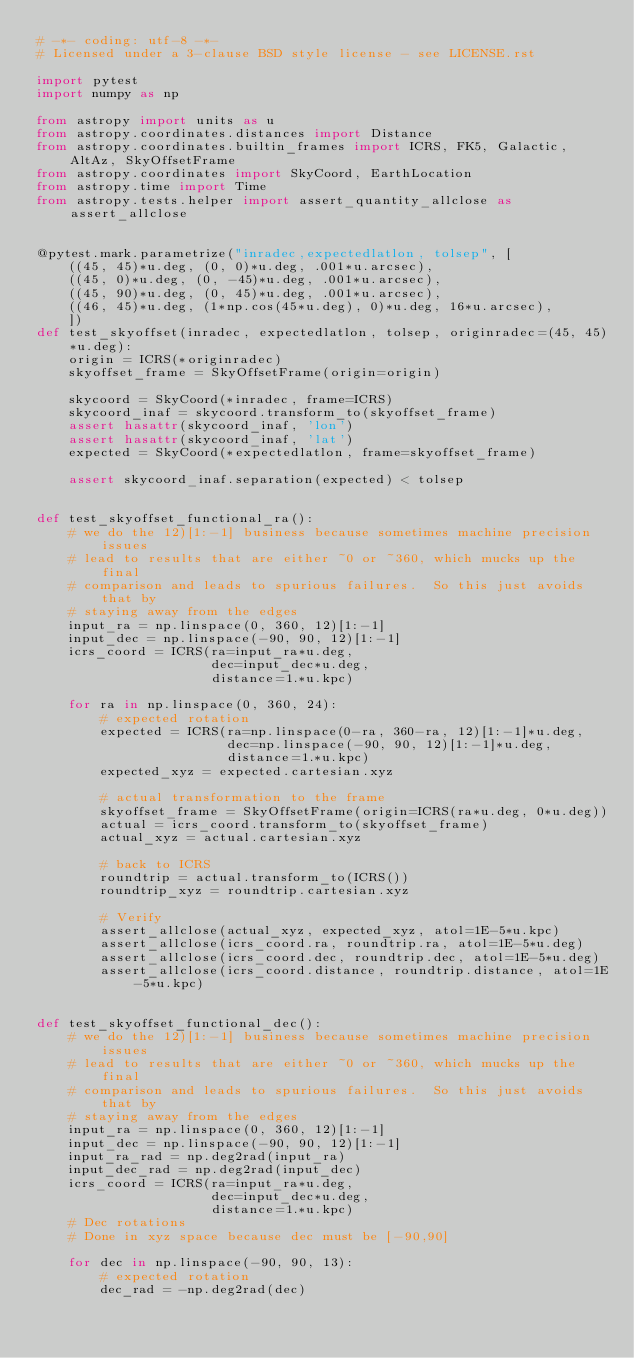<code> <loc_0><loc_0><loc_500><loc_500><_Python_># -*- coding: utf-8 -*-
# Licensed under a 3-clause BSD style license - see LICENSE.rst

import pytest
import numpy as np

from astropy import units as u
from astropy.coordinates.distances import Distance
from astropy.coordinates.builtin_frames import ICRS, FK5, Galactic, AltAz, SkyOffsetFrame
from astropy.coordinates import SkyCoord, EarthLocation
from astropy.time import Time
from astropy.tests.helper import assert_quantity_allclose as assert_allclose


@pytest.mark.parametrize("inradec,expectedlatlon, tolsep", [
    ((45, 45)*u.deg, (0, 0)*u.deg, .001*u.arcsec),
    ((45, 0)*u.deg, (0, -45)*u.deg, .001*u.arcsec),
    ((45, 90)*u.deg, (0, 45)*u.deg, .001*u.arcsec),
    ((46, 45)*u.deg, (1*np.cos(45*u.deg), 0)*u.deg, 16*u.arcsec),
    ])
def test_skyoffset(inradec, expectedlatlon, tolsep, originradec=(45, 45)*u.deg):
    origin = ICRS(*originradec)
    skyoffset_frame = SkyOffsetFrame(origin=origin)

    skycoord = SkyCoord(*inradec, frame=ICRS)
    skycoord_inaf = skycoord.transform_to(skyoffset_frame)
    assert hasattr(skycoord_inaf, 'lon')
    assert hasattr(skycoord_inaf, 'lat')
    expected = SkyCoord(*expectedlatlon, frame=skyoffset_frame)

    assert skycoord_inaf.separation(expected) < tolsep


def test_skyoffset_functional_ra():
    # we do the 12)[1:-1] business because sometimes machine precision issues
    # lead to results that are either ~0 or ~360, which mucks up the final
    # comparison and leads to spurious failures.  So this just avoids that by
    # staying away from the edges
    input_ra = np.linspace(0, 360, 12)[1:-1]
    input_dec = np.linspace(-90, 90, 12)[1:-1]
    icrs_coord = ICRS(ra=input_ra*u.deg,
                      dec=input_dec*u.deg,
                      distance=1.*u.kpc)

    for ra in np.linspace(0, 360, 24):
        # expected rotation
        expected = ICRS(ra=np.linspace(0-ra, 360-ra, 12)[1:-1]*u.deg,
                        dec=np.linspace(-90, 90, 12)[1:-1]*u.deg,
                        distance=1.*u.kpc)
        expected_xyz = expected.cartesian.xyz

        # actual transformation to the frame
        skyoffset_frame = SkyOffsetFrame(origin=ICRS(ra*u.deg, 0*u.deg))
        actual = icrs_coord.transform_to(skyoffset_frame)
        actual_xyz = actual.cartesian.xyz

        # back to ICRS
        roundtrip = actual.transform_to(ICRS())
        roundtrip_xyz = roundtrip.cartesian.xyz

        # Verify
        assert_allclose(actual_xyz, expected_xyz, atol=1E-5*u.kpc)
        assert_allclose(icrs_coord.ra, roundtrip.ra, atol=1E-5*u.deg)
        assert_allclose(icrs_coord.dec, roundtrip.dec, atol=1E-5*u.deg)
        assert_allclose(icrs_coord.distance, roundtrip.distance, atol=1E-5*u.kpc)


def test_skyoffset_functional_dec():
    # we do the 12)[1:-1] business because sometimes machine precision issues
    # lead to results that are either ~0 or ~360, which mucks up the final
    # comparison and leads to spurious failures.  So this just avoids that by
    # staying away from the edges
    input_ra = np.linspace(0, 360, 12)[1:-1]
    input_dec = np.linspace(-90, 90, 12)[1:-1]
    input_ra_rad = np.deg2rad(input_ra)
    input_dec_rad = np.deg2rad(input_dec)
    icrs_coord = ICRS(ra=input_ra*u.deg,
                      dec=input_dec*u.deg,
                      distance=1.*u.kpc)
    # Dec rotations
    # Done in xyz space because dec must be [-90,90]

    for dec in np.linspace(-90, 90, 13):
        # expected rotation
        dec_rad = -np.deg2rad(dec)</code> 